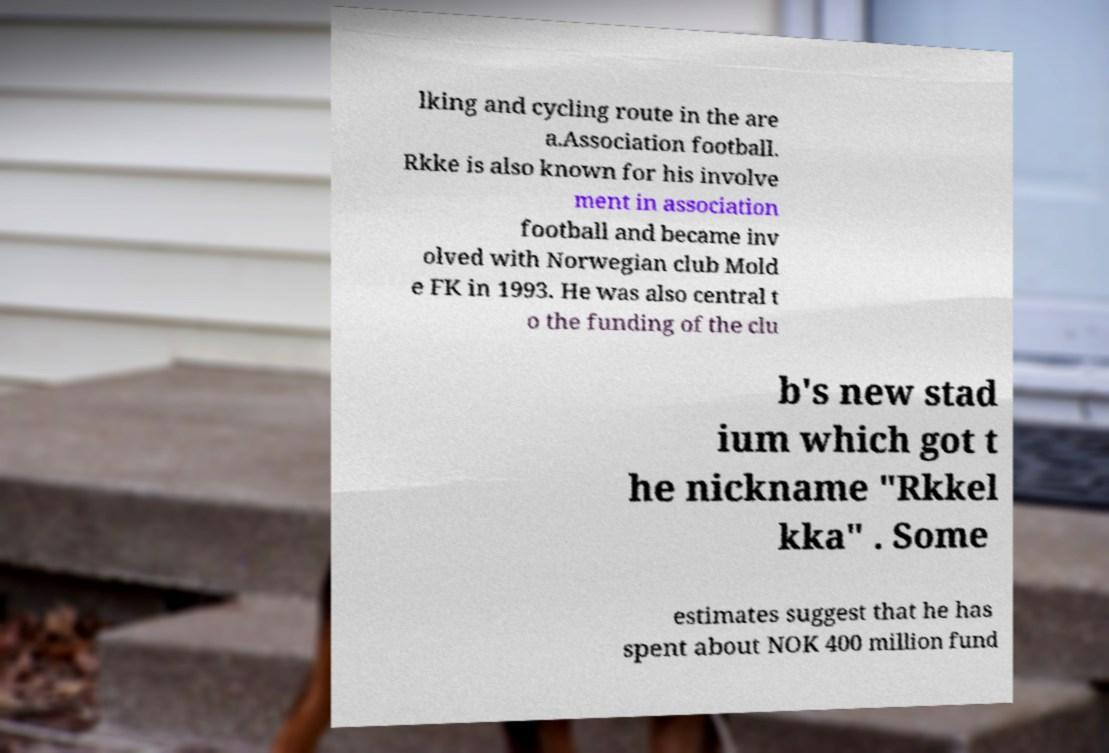Please identify and transcribe the text found in this image. lking and cycling route in the are a.Association football. Rkke is also known for his involve ment in association football and became inv olved with Norwegian club Mold e FK in 1993. He was also central t o the funding of the clu b's new stad ium which got t he nickname "Rkkel kka" . Some estimates suggest that he has spent about NOK 400 million fund 